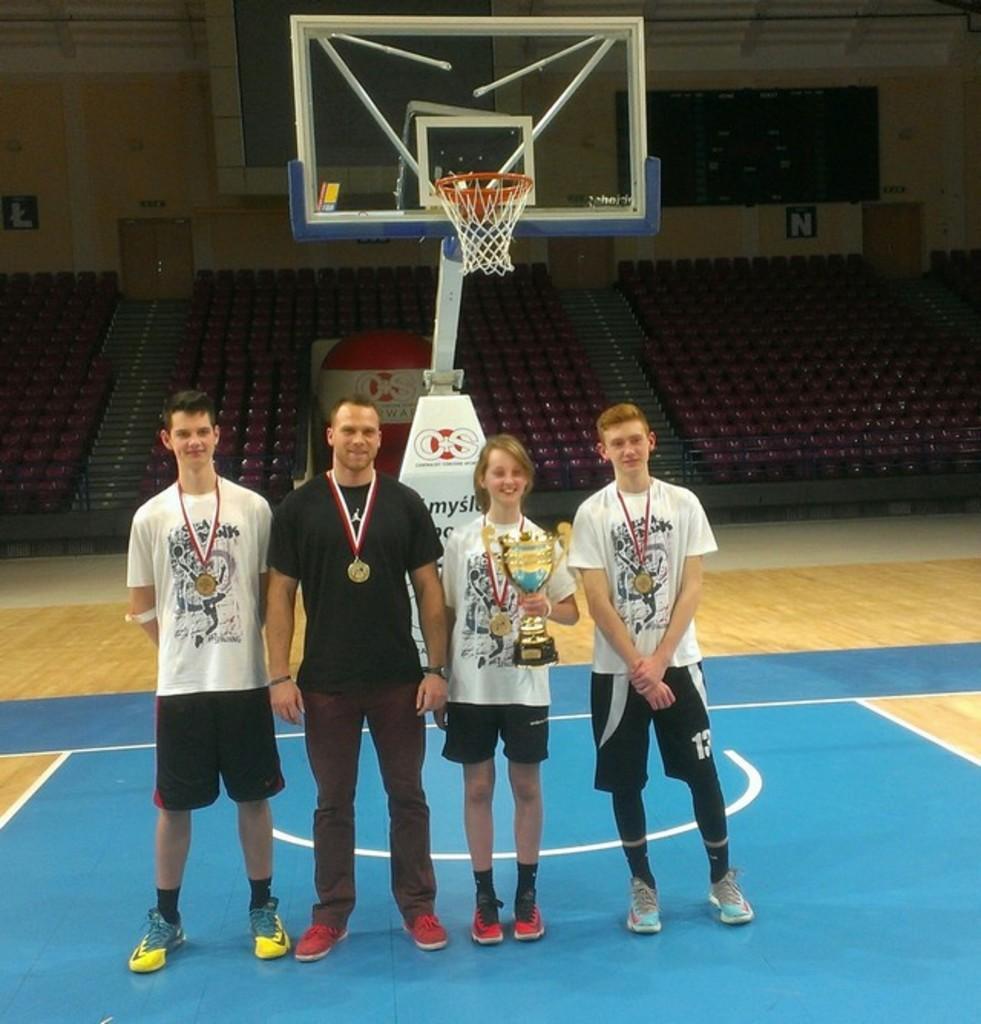Could you give a brief overview of what you see in this image? In this image I can see a basketball court in the front and on it I can see few people are standing. I can see they all are wearing t shirt and medals. I can see one of them is holding a cup. In the background I can see number of chairs a board and on it I can see a basket. 